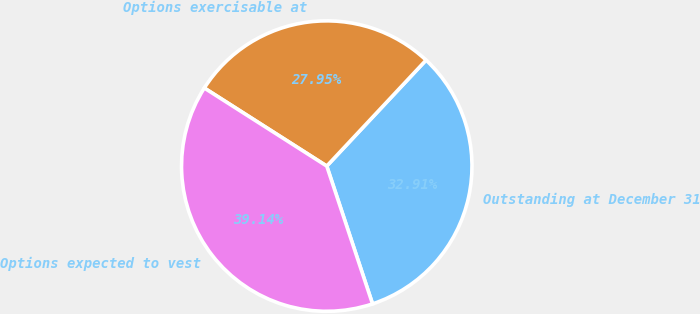Convert chart. <chart><loc_0><loc_0><loc_500><loc_500><pie_chart><fcel>Outstanding at December 31<fcel>Options exercisable at<fcel>Options expected to vest<nl><fcel>32.91%<fcel>27.95%<fcel>39.14%<nl></chart> 